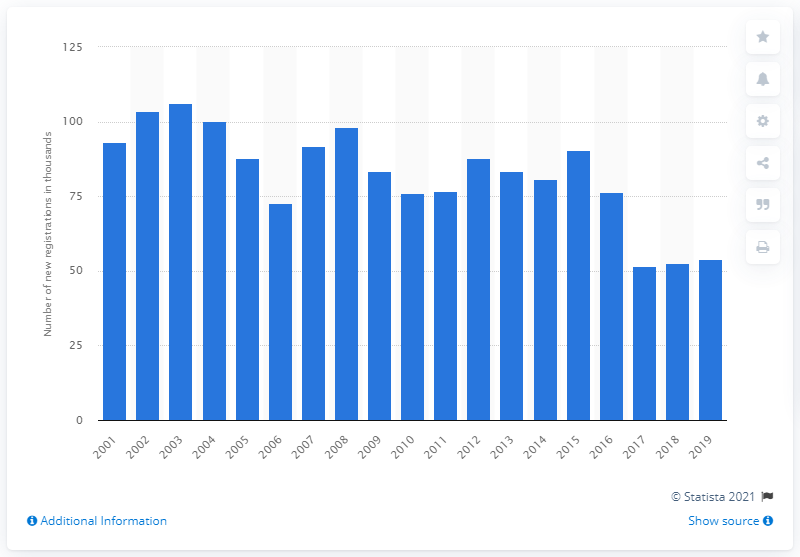Outline some significant characteristics in this image. A peak in sales of the Vauxhall Corsa was observed in 2003. 